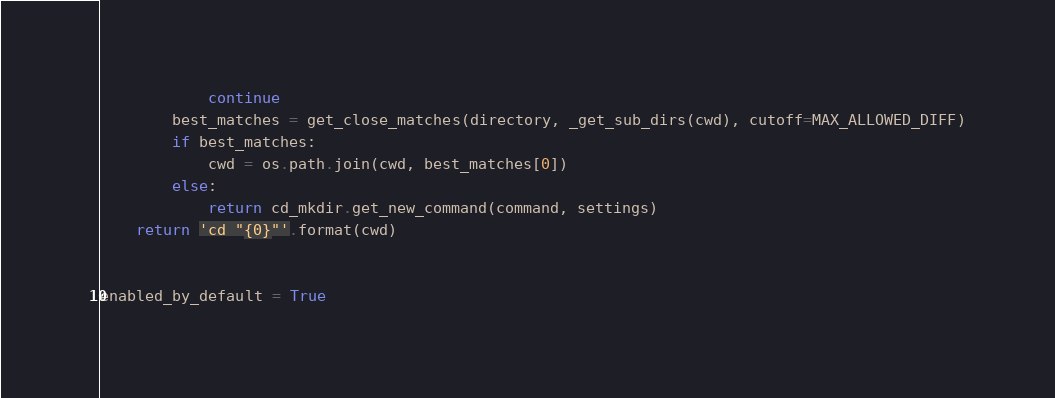Convert code to text. <code><loc_0><loc_0><loc_500><loc_500><_Python_>            continue
        best_matches = get_close_matches(directory, _get_sub_dirs(cwd), cutoff=MAX_ALLOWED_DIFF)
        if best_matches:
            cwd = os.path.join(cwd, best_matches[0])
        else:
            return cd_mkdir.get_new_command(command, settings)
    return 'cd "{0}"'.format(cwd)


enabled_by_default = True
</code> 